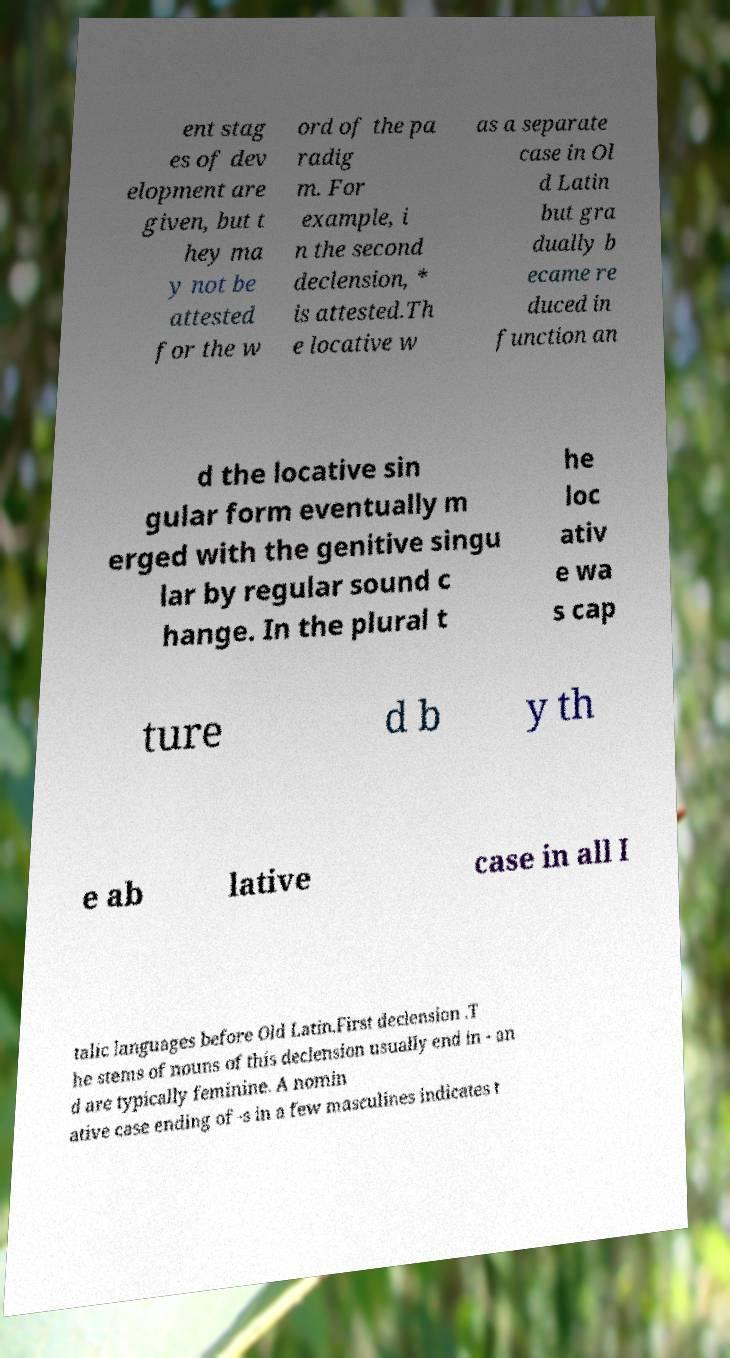I need the written content from this picture converted into text. Can you do that? ent stag es of dev elopment are given, but t hey ma y not be attested for the w ord of the pa radig m. For example, i n the second declension, * is attested.Th e locative w as a separate case in Ol d Latin but gra dually b ecame re duced in function an d the locative sin gular form eventually m erged with the genitive singu lar by regular sound c hange. In the plural t he loc ativ e wa s cap ture d b y th e ab lative case in all I talic languages before Old Latin.First declension .T he stems of nouns of this declension usually end in - an d are typically feminine. A nomin ative case ending of -s in a few masculines indicates t 